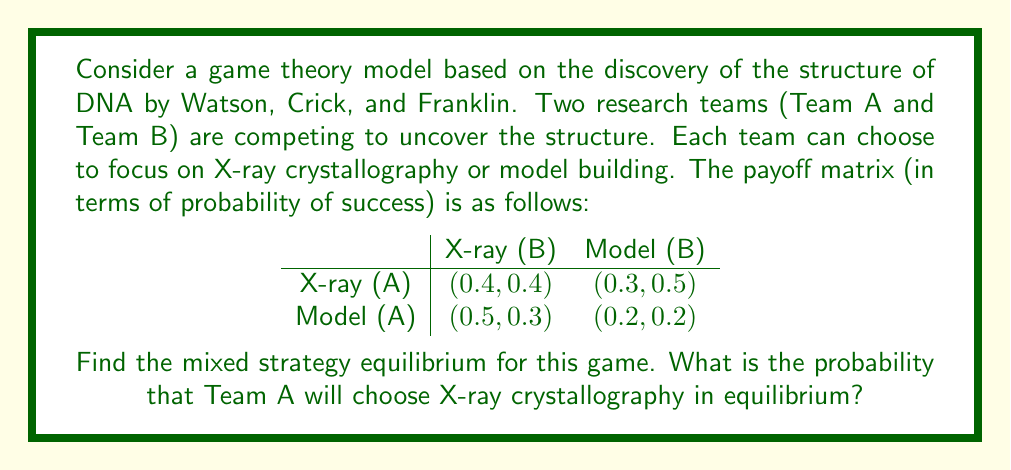Teach me how to tackle this problem. To find the mixed strategy equilibrium, we need to make each team indifferent between their two strategies. Let's solve this step-by-step:

1) Let $p$ be the probability that Team B chooses X-ray crystallography. Then, $1-p$ is the probability they choose model building.

2) For Team A to be indifferent, the expected payoff from X-ray must equal the expected payoff from model building:

   $$0.4p + 0.3(1-p) = 0.5p + 0.2(1-p)$$

3) Simplify the equation:

   $$0.4p + 0.3 - 0.3p = 0.5p + 0.2 - 0.2p$$
   $$0.4p + 0.3 - 0.3p = 0.3p + 0.2$$

4) Solve for $p$:

   $$0.1p + 0.3 = 0.2$$
   $$0.1p = -0.1$$
   $$p = -1$$

5) Since $p$ is a probability, it can't be negative. This means Team B will never play X-ray in equilibrium $(p=0)$.

6) Now, let $q$ be the probability that Team A chooses X-ray crystallography.

7) For Team B to be indifferent when they always choose model building:

   $$0.5q + 0.2(1-q) = 0.2$$

8) Solve for $q$:

   $$0.5q + 0.2 - 0.2q = 0.2$$
   $$0.3q = 0$$
   $$q = 0$$

Therefore, in the mixed strategy equilibrium, both teams will always choose model building.
Answer: The probability that Team A will choose X-ray crystallography in equilibrium is 0. 